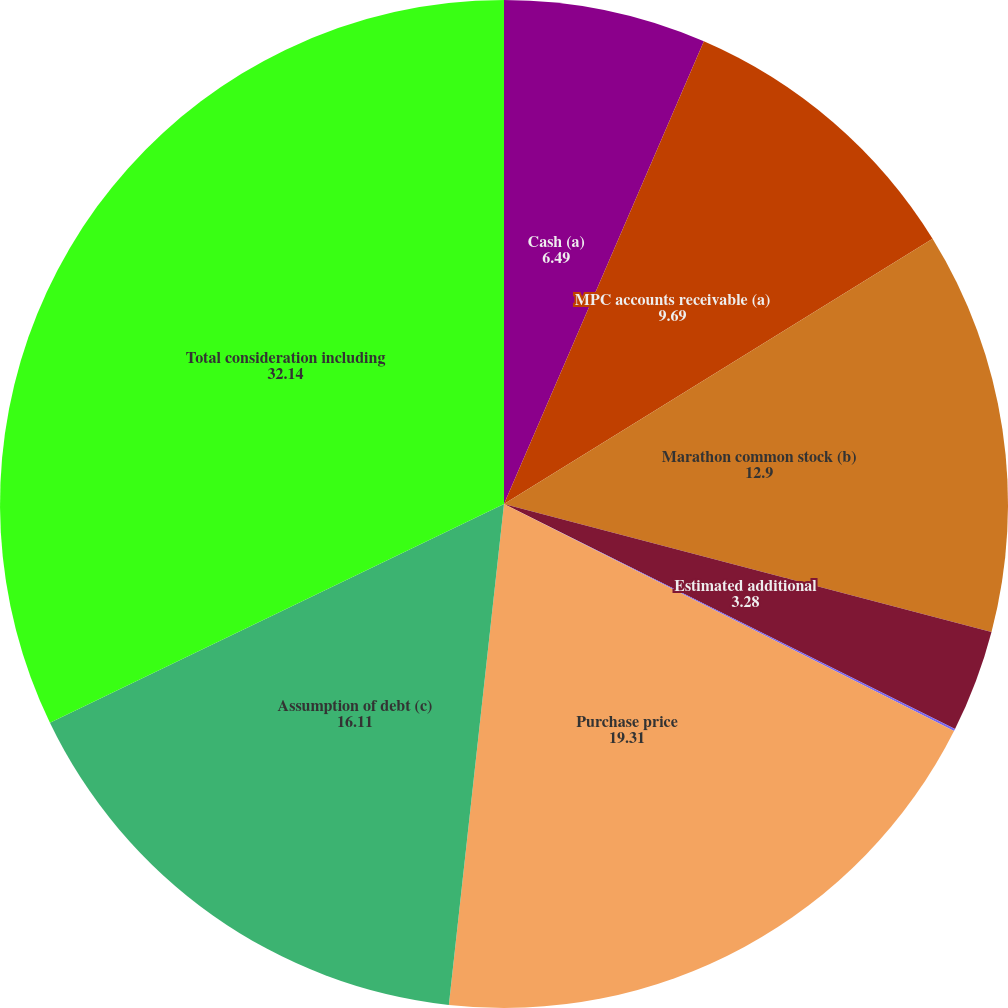Convert chart to OTSL. <chart><loc_0><loc_0><loc_500><loc_500><pie_chart><fcel>Cash (a)<fcel>MPC accounts receivable (a)<fcel>Marathon common stock (b)<fcel>Estimated additional<fcel>Transaction-related costs<fcel>Purchase price<fcel>Assumption of debt (c)<fcel>Total consideration including<nl><fcel>6.49%<fcel>9.69%<fcel>12.9%<fcel>3.28%<fcel>0.07%<fcel>19.31%<fcel>16.11%<fcel>32.14%<nl></chart> 